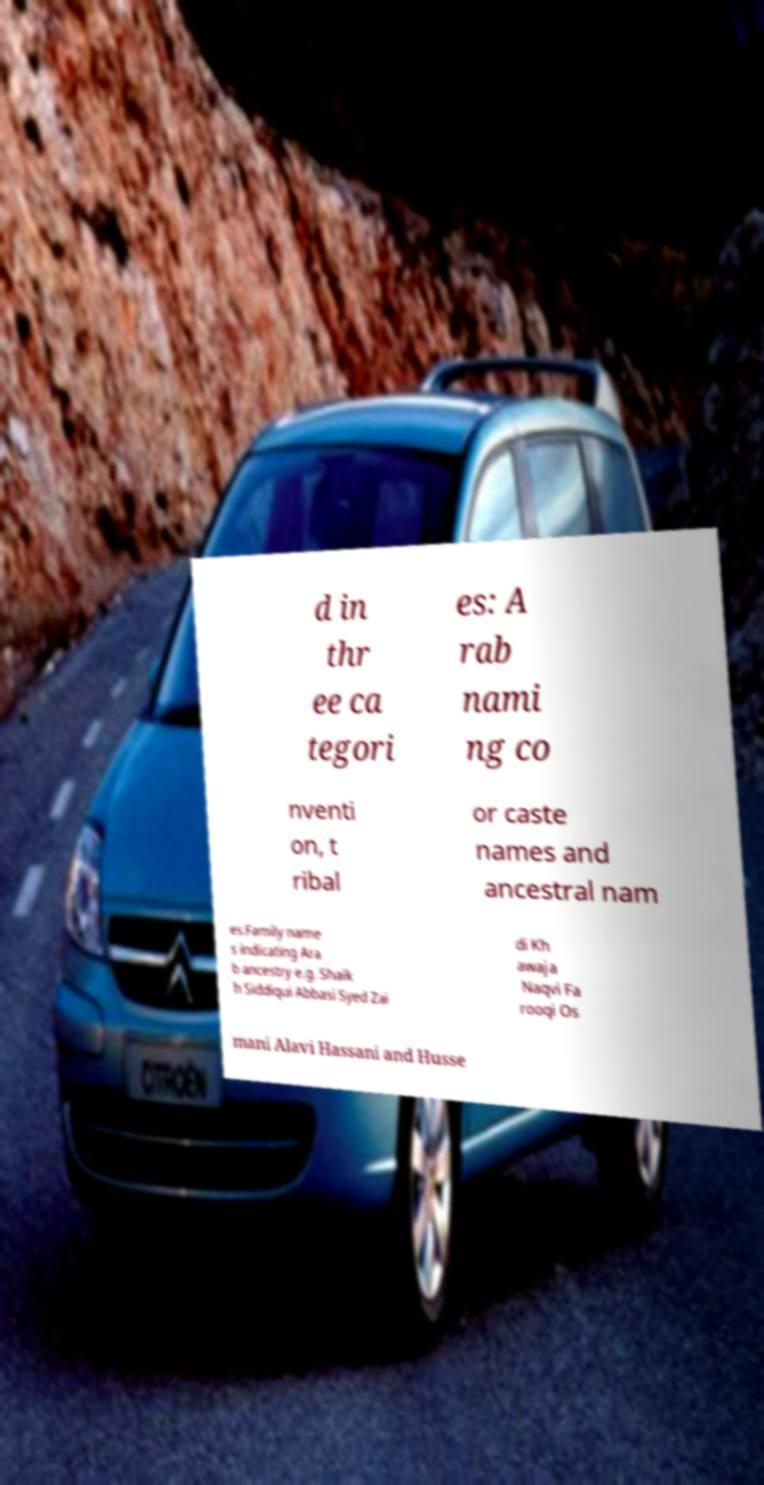Please read and relay the text visible in this image. What does it say? d in thr ee ca tegori es: A rab nami ng co nventi on, t ribal or caste names and ancestral nam es.Family name s indicating Ara b ancestry e.g. Shaik h Siddiqui Abbasi Syed Zai di Kh awaja Naqvi Fa rooqi Os mani Alavi Hassani and Husse 